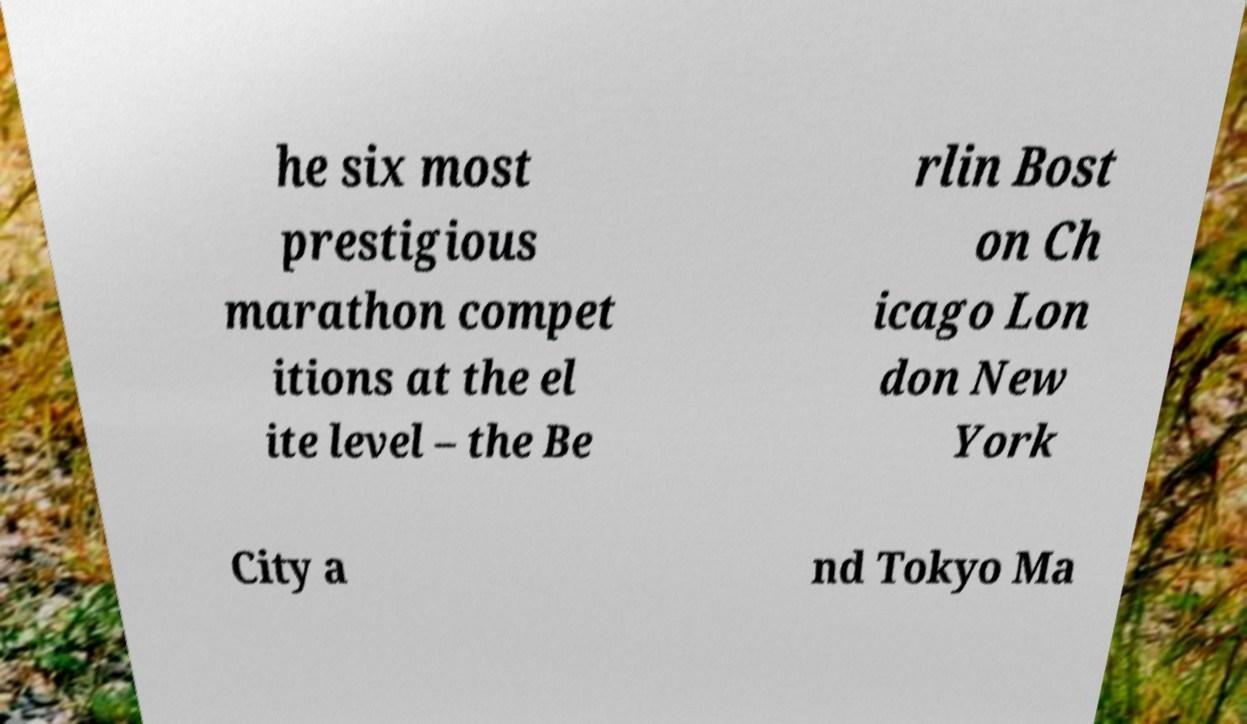What messages or text are displayed in this image? I need them in a readable, typed format. he six most prestigious marathon compet itions at the el ite level – the Be rlin Bost on Ch icago Lon don New York City a nd Tokyo Ma 